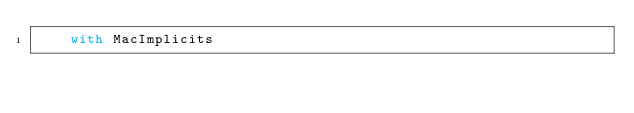<code> <loc_0><loc_0><loc_500><loc_500><_Scala_>    with MacImplicits
</code> 